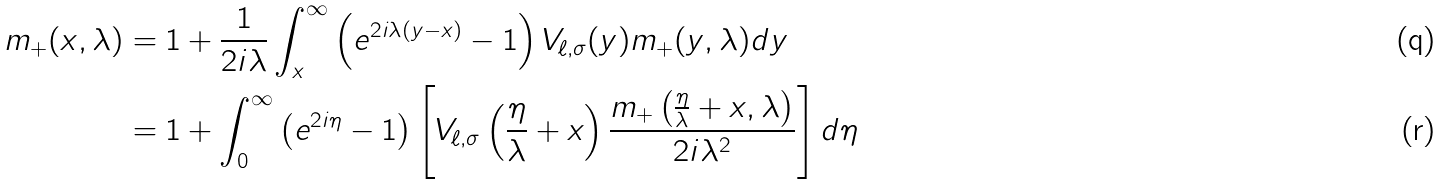Convert formula to latex. <formula><loc_0><loc_0><loc_500><loc_500>m _ { + } ( x , \lambda ) & = 1 + \frac { 1 } { 2 i \lambda } \int _ { x } ^ { \infty } \left ( e ^ { 2 i \lambda ( y - x ) } - 1 \right ) V _ { \ell , \sigma } ( y ) m _ { + } ( y , \lambda ) d y \\ & = 1 + \int _ { 0 } ^ { \infty } \left ( e ^ { 2 i \eta } - 1 \right ) \left [ V _ { \ell , \sigma } \left ( \frac { \eta } { \lambda } + x \right ) \frac { m _ { + } \left ( \frac { \eta } { \lambda } + x , \lambda \right ) } { 2 i \lambda ^ { 2 } } \right ] d \eta</formula> 